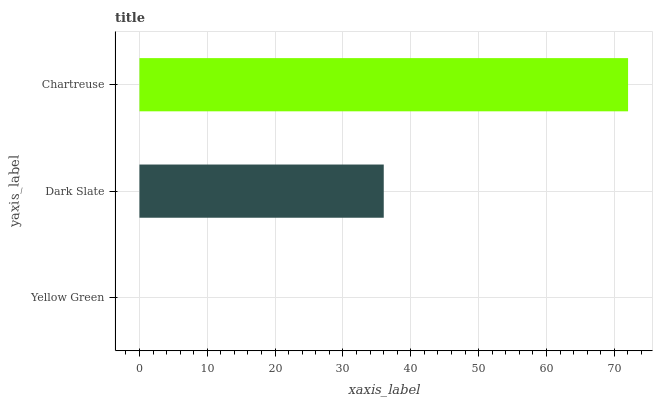Is Yellow Green the minimum?
Answer yes or no. Yes. Is Chartreuse the maximum?
Answer yes or no. Yes. Is Dark Slate the minimum?
Answer yes or no. No. Is Dark Slate the maximum?
Answer yes or no. No. Is Dark Slate greater than Yellow Green?
Answer yes or no. Yes. Is Yellow Green less than Dark Slate?
Answer yes or no. Yes. Is Yellow Green greater than Dark Slate?
Answer yes or no. No. Is Dark Slate less than Yellow Green?
Answer yes or no. No. Is Dark Slate the high median?
Answer yes or no. Yes. Is Dark Slate the low median?
Answer yes or no. Yes. Is Chartreuse the high median?
Answer yes or no. No. Is Chartreuse the low median?
Answer yes or no. No. 